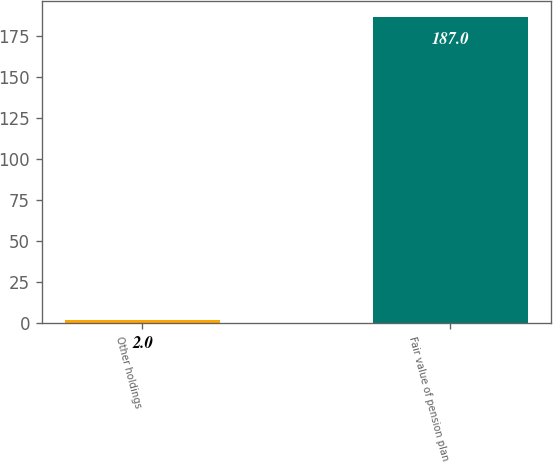Convert chart to OTSL. <chart><loc_0><loc_0><loc_500><loc_500><bar_chart><fcel>Other holdings<fcel>Fair value of pension plan<nl><fcel>2<fcel>187<nl></chart> 